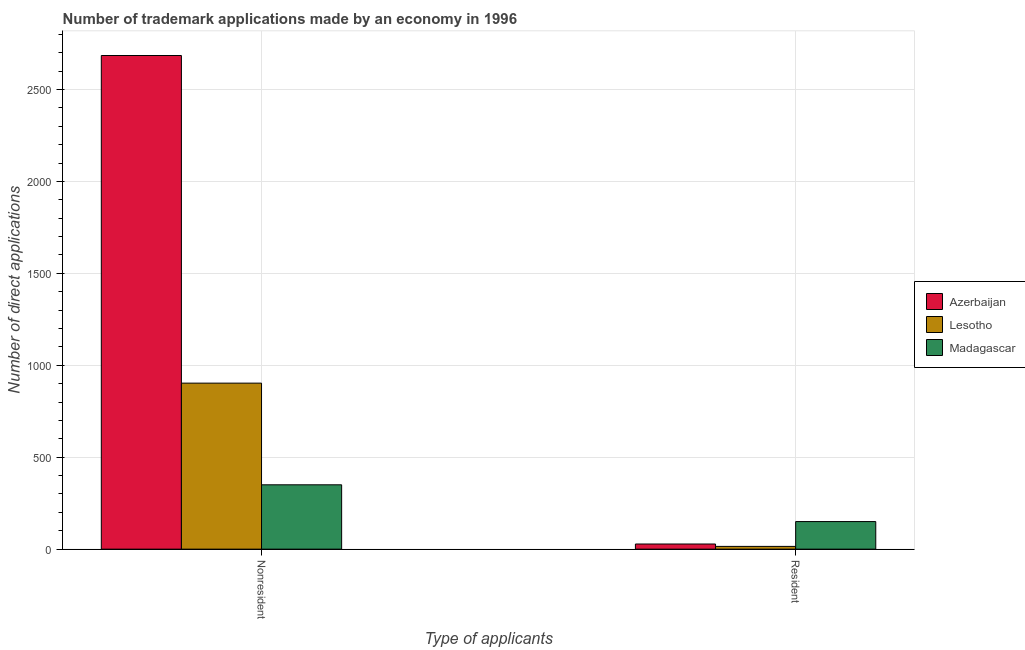How many groups of bars are there?
Ensure brevity in your answer.  2. Are the number of bars per tick equal to the number of legend labels?
Keep it short and to the point. Yes. How many bars are there on the 1st tick from the left?
Provide a succinct answer. 3. How many bars are there on the 1st tick from the right?
Give a very brief answer. 3. What is the label of the 2nd group of bars from the left?
Ensure brevity in your answer.  Resident. What is the number of trademark applications made by non residents in Lesotho?
Give a very brief answer. 903. Across all countries, what is the maximum number of trademark applications made by non residents?
Your response must be concise. 2685. Across all countries, what is the minimum number of trademark applications made by residents?
Provide a succinct answer. 15. In which country was the number of trademark applications made by non residents maximum?
Offer a terse response. Azerbaijan. In which country was the number of trademark applications made by non residents minimum?
Provide a short and direct response. Madagascar. What is the total number of trademark applications made by non residents in the graph?
Keep it short and to the point. 3938. What is the difference between the number of trademark applications made by non residents in Madagascar and that in Lesotho?
Ensure brevity in your answer.  -553. What is the difference between the number of trademark applications made by non residents in Madagascar and the number of trademark applications made by residents in Azerbaijan?
Provide a short and direct response. 322. What is the average number of trademark applications made by residents per country?
Provide a short and direct response. 64.33. What is the difference between the number of trademark applications made by non residents and number of trademark applications made by residents in Lesotho?
Your response must be concise. 888. In how many countries, is the number of trademark applications made by non residents greater than 1700 ?
Offer a terse response. 1. What is the ratio of the number of trademark applications made by non residents in Lesotho to that in Madagascar?
Offer a very short reply. 2.58. Is the number of trademark applications made by non residents in Azerbaijan less than that in Lesotho?
Ensure brevity in your answer.  No. In how many countries, is the number of trademark applications made by non residents greater than the average number of trademark applications made by non residents taken over all countries?
Ensure brevity in your answer.  1. What does the 1st bar from the left in Nonresident represents?
Provide a succinct answer. Azerbaijan. What does the 1st bar from the right in Nonresident represents?
Give a very brief answer. Madagascar. How many bars are there?
Your answer should be very brief. 6. Are all the bars in the graph horizontal?
Give a very brief answer. No. Are the values on the major ticks of Y-axis written in scientific E-notation?
Provide a succinct answer. No. Does the graph contain any zero values?
Make the answer very short. No. Does the graph contain grids?
Offer a very short reply. Yes. Where does the legend appear in the graph?
Keep it short and to the point. Center right. What is the title of the graph?
Your answer should be compact. Number of trademark applications made by an economy in 1996. Does "Upper middle income" appear as one of the legend labels in the graph?
Provide a short and direct response. No. What is the label or title of the X-axis?
Provide a succinct answer. Type of applicants. What is the label or title of the Y-axis?
Your answer should be compact. Number of direct applications. What is the Number of direct applications in Azerbaijan in Nonresident?
Your answer should be very brief. 2685. What is the Number of direct applications in Lesotho in Nonresident?
Provide a succinct answer. 903. What is the Number of direct applications in Madagascar in Nonresident?
Ensure brevity in your answer.  350. What is the Number of direct applications of Azerbaijan in Resident?
Offer a very short reply. 28. What is the Number of direct applications in Madagascar in Resident?
Provide a short and direct response. 150. Across all Type of applicants, what is the maximum Number of direct applications of Azerbaijan?
Give a very brief answer. 2685. Across all Type of applicants, what is the maximum Number of direct applications in Lesotho?
Keep it short and to the point. 903. Across all Type of applicants, what is the maximum Number of direct applications in Madagascar?
Make the answer very short. 350. Across all Type of applicants, what is the minimum Number of direct applications of Madagascar?
Your answer should be compact. 150. What is the total Number of direct applications of Azerbaijan in the graph?
Offer a terse response. 2713. What is the total Number of direct applications in Lesotho in the graph?
Give a very brief answer. 918. What is the total Number of direct applications of Madagascar in the graph?
Offer a terse response. 500. What is the difference between the Number of direct applications in Azerbaijan in Nonresident and that in Resident?
Provide a succinct answer. 2657. What is the difference between the Number of direct applications in Lesotho in Nonresident and that in Resident?
Your answer should be very brief. 888. What is the difference between the Number of direct applications of Madagascar in Nonresident and that in Resident?
Keep it short and to the point. 200. What is the difference between the Number of direct applications in Azerbaijan in Nonresident and the Number of direct applications in Lesotho in Resident?
Offer a very short reply. 2670. What is the difference between the Number of direct applications in Azerbaijan in Nonresident and the Number of direct applications in Madagascar in Resident?
Offer a very short reply. 2535. What is the difference between the Number of direct applications of Lesotho in Nonresident and the Number of direct applications of Madagascar in Resident?
Offer a terse response. 753. What is the average Number of direct applications in Azerbaijan per Type of applicants?
Your answer should be compact. 1356.5. What is the average Number of direct applications of Lesotho per Type of applicants?
Your answer should be very brief. 459. What is the average Number of direct applications of Madagascar per Type of applicants?
Provide a short and direct response. 250. What is the difference between the Number of direct applications in Azerbaijan and Number of direct applications in Lesotho in Nonresident?
Give a very brief answer. 1782. What is the difference between the Number of direct applications of Azerbaijan and Number of direct applications of Madagascar in Nonresident?
Your answer should be very brief. 2335. What is the difference between the Number of direct applications in Lesotho and Number of direct applications in Madagascar in Nonresident?
Make the answer very short. 553. What is the difference between the Number of direct applications in Azerbaijan and Number of direct applications in Madagascar in Resident?
Make the answer very short. -122. What is the difference between the Number of direct applications in Lesotho and Number of direct applications in Madagascar in Resident?
Keep it short and to the point. -135. What is the ratio of the Number of direct applications of Azerbaijan in Nonresident to that in Resident?
Give a very brief answer. 95.89. What is the ratio of the Number of direct applications of Lesotho in Nonresident to that in Resident?
Ensure brevity in your answer.  60.2. What is the ratio of the Number of direct applications of Madagascar in Nonresident to that in Resident?
Offer a very short reply. 2.33. What is the difference between the highest and the second highest Number of direct applications in Azerbaijan?
Your response must be concise. 2657. What is the difference between the highest and the second highest Number of direct applications in Lesotho?
Provide a succinct answer. 888. What is the difference between the highest and the lowest Number of direct applications in Azerbaijan?
Give a very brief answer. 2657. What is the difference between the highest and the lowest Number of direct applications of Lesotho?
Your answer should be very brief. 888. 